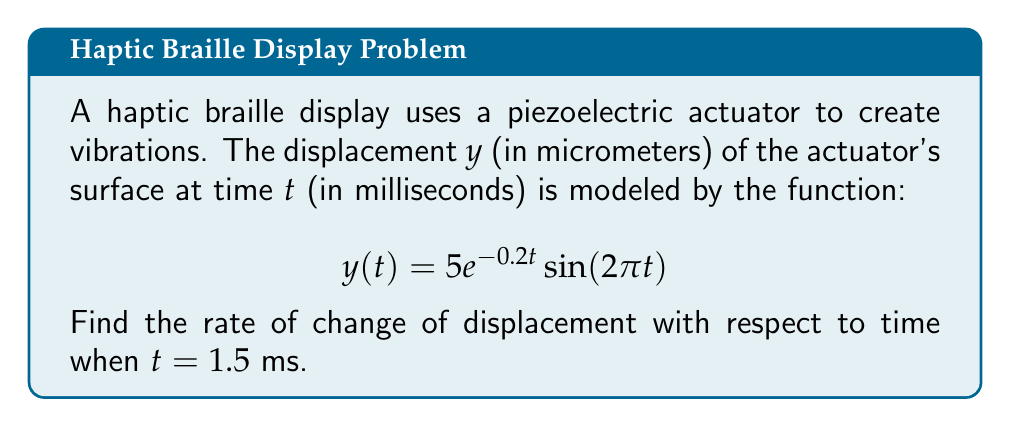Show me your answer to this math problem. To find the rate of change of displacement with respect to time, we need to differentiate $y(t)$ and then evaluate it at $t = 1.5$.

1) First, let's use the product rule to differentiate $y(t) = 5e^{-0.2t}\sin(2\pi t)$:

   $$\frac{dy}{dt} = 5\frac{d}{dt}(e^{-0.2t})\sin(2\pi t) + 5e^{-0.2t}\frac{d}{dt}(\sin(2\pi t))$$

2) Differentiate each part:
   - $\frac{d}{dt}(e^{-0.2t}) = -0.2e^{-0.2t}$
   - $\frac{d}{dt}(\sin(2\pi t)) = 2\pi \cos(2\pi t)$

3) Substitute these back into the equation:

   $$\frac{dy}{dt} = 5(-0.2e^{-0.2t})\sin(2\pi t) + 5e^{-0.2t}(2\pi \cos(2\pi t))$$

4) Simplify:

   $$\frac{dy}{dt} = -e^{-0.2t}\sin(2\pi t) + 10\pi e^{-0.2t}\cos(2\pi t)$$

5) Now, evaluate this at $t = 1.5$:

   $$\frac{dy}{dt}\bigg|_{t=1.5} = -e^{-0.2(1.5)}\sin(2\pi(1.5)) + 10\pi e^{-0.2(1.5)}\cos(2\pi(1.5))$$

6) Calculate the values:
   - $e^{-0.2(1.5)} \approx 0.7408$
   - $\sin(2\pi(1.5)) = \sin(3\pi) = 0$
   - $\cos(2\pi(1.5)) = \cos(3\pi) = -1$

7) Substitute these values:

   $$\frac{dy}{dt}\bigg|_{t=1.5} = -0.7408(0) + 10\pi(0.7408)(-1) \approx -23.2799$$

Therefore, the rate of change of displacement at $t = 1.5$ ms is approximately -23.2799 μm/ms.
Answer: $-23.2799$ μm/ms 